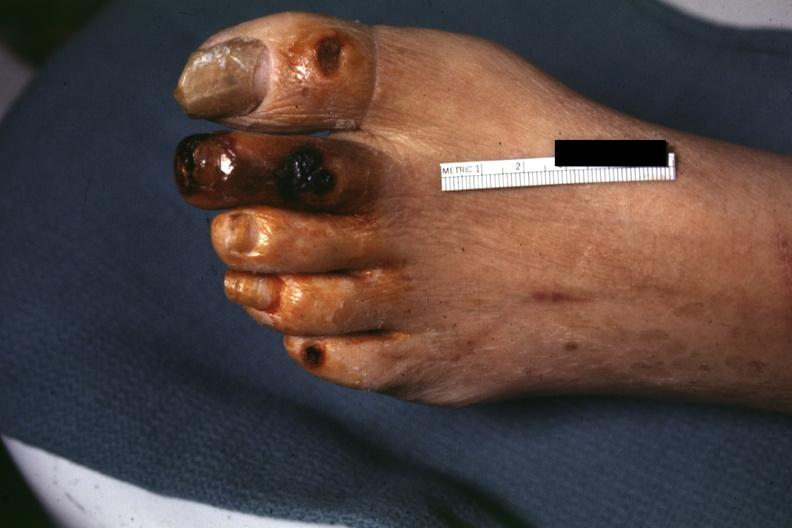re mitotic figures present?
Answer the question using a single word or phrase. No 